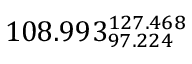Convert formula to latex. <formula><loc_0><loc_0><loc_500><loc_500>1 0 8 . 9 9 3 _ { 9 7 . 2 2 4 } ^ { 1 2 7 . 4 6 8 }</formula> 